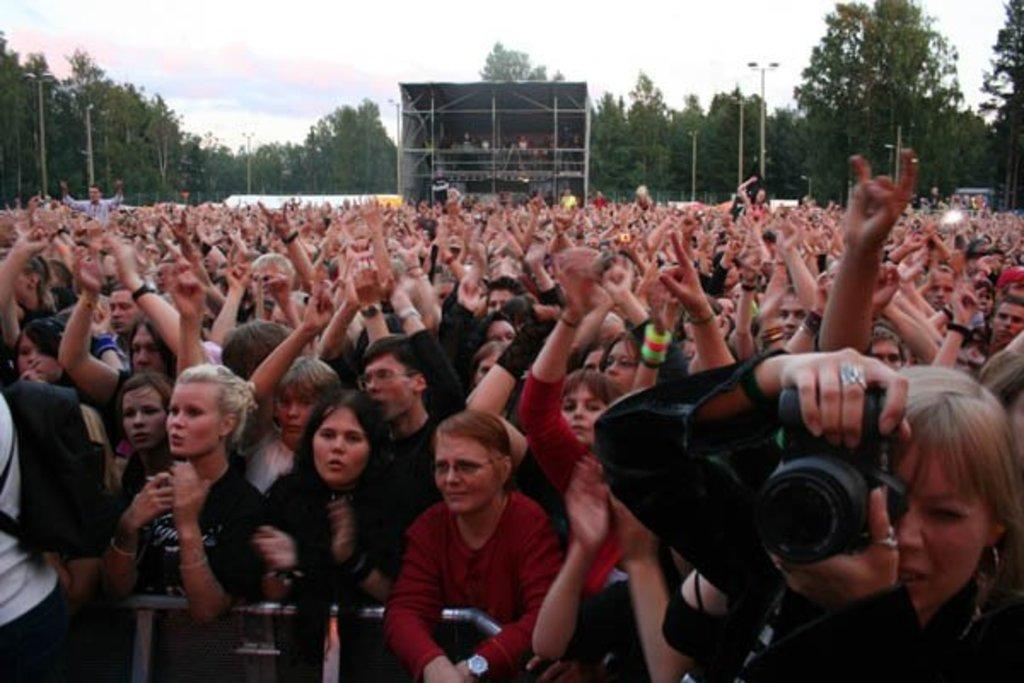What can be seen in the image? There are people standing in the image. What is visible in the background of the image? There are trees and clouds visible in the background of the image. What is the woman in the image holding? A woman is holding a camera in the image. What type of pollution can be seen in the image? There is no pollution visible in the image. How many beans are present in the image? There are no beans present in the image. 